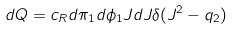Convert formula to latex. <formula><loc_0><loc_0><loc_500><loc_500>d Q = c _ { R } d \pi _ { 1 } d \phi _ { 1 } J d J \delta ( J ^ { 2 } - q _ { 2 } )</formula> 